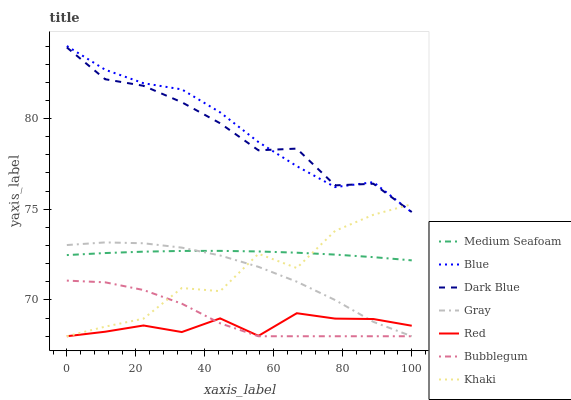Does Red have the minimum area under the curve?
Answer yes or no. Yes. Does Blue have the maximum area under the curve?
Answer yes or no. Yes. Does Gray have the minimum area under the curve?
Answer yes or no. No. Does Gray have the maximum area under the curve?
Answer yes or no. No. Is Medium Seafoam the smoothest?
Answer yes or no. Yes. Is Khaki the roughest?
Answer yes or no. Yes. Is Gray the smoothest?
Answer yes or no. No. Is Gray the roughest?
Answer yes or no. No. Does Gray have the lowest value?
Answer yes or no. Yes. Does Dark Blue have the lowest value?
Answer yes or no. No. Does Blue have the highest value?
Answer yes or no. Yes. Does Gray have the highest value?
Answer yes or no. No. Is Gray less than Dark Blue?
Answer yes or no. Yes. Is Medium Seafoam greater than Bubblegum?
Answer yes or no. Yes. Does Bubblegum intersect Gray?
Answer yes or no. Yes. Is Bubblegum less than Gray?
Answer yes or no. No. Is Bubblegum greater than Gray?
Answer yes or no. No. Does Gray intersect Dark Blue?
Answer yes or no. No. 